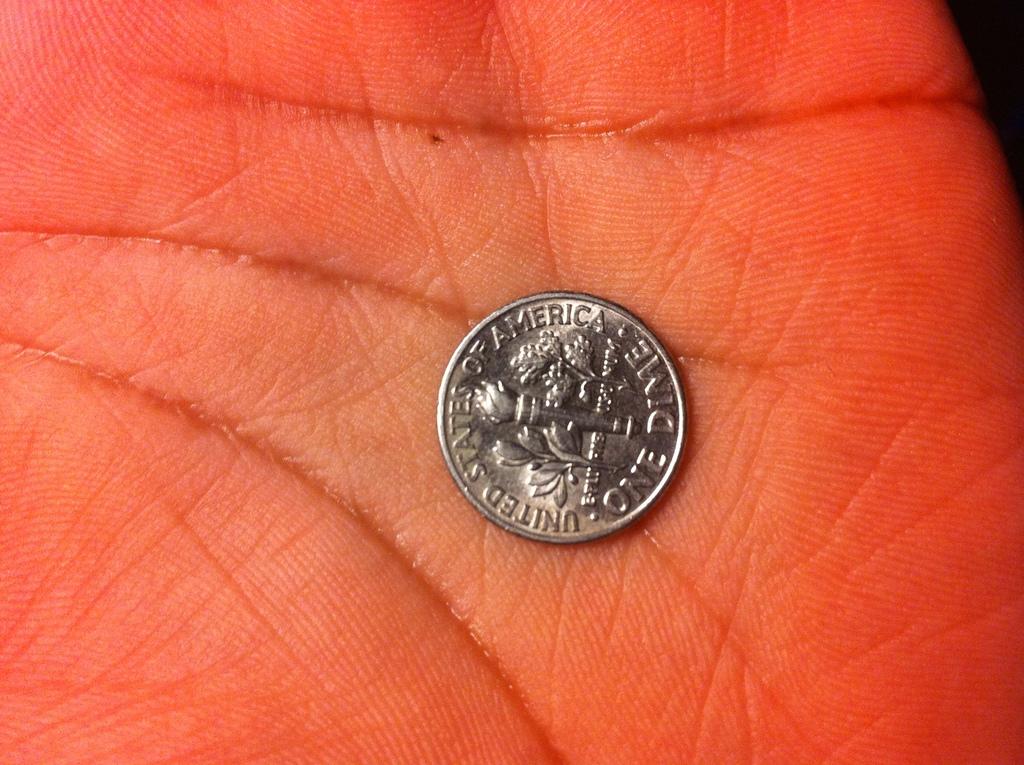How many different languages are used in the writing on this dime?
Offer a terse response. 2. What does the dime have stamped on it?
Your response must be concise. United states of america one dime. 